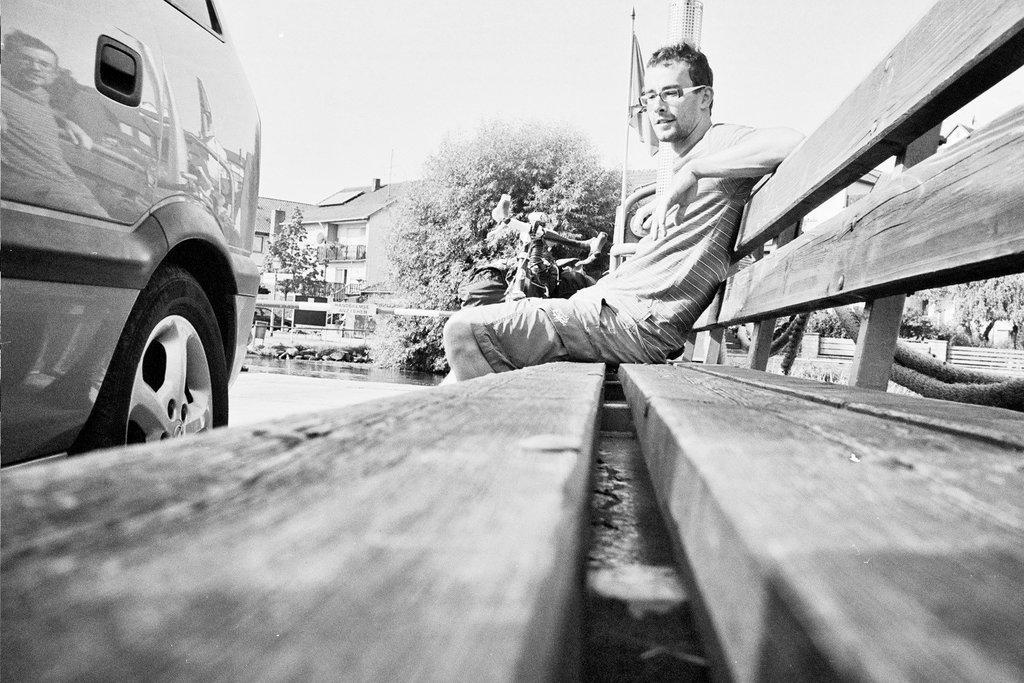How would you summarize this image in a sentence or two? This picture is in black and white. Here, we see the man who is wearing spectacles is sitting on the bench. Beside him, we see a tower and a flag. In front of him, we see a car is moving on the road. There are trees and buildings in the background. We even see the cars moving in the background. At the top of the picture, we see the sky. This picture is clicked outside the city. 